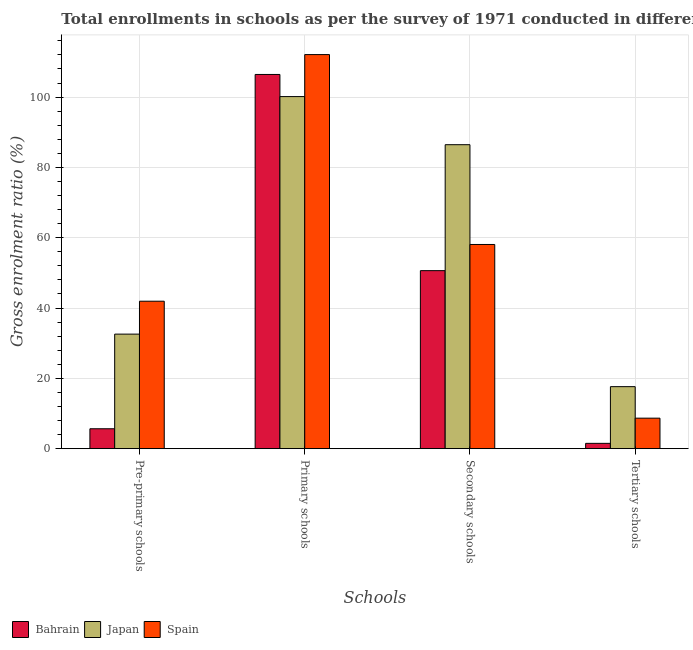How many different coloured bars are there?
Your answer should be very brief. 3. How many groups of bars are there?
Ensure brevity in your answer.  4. Are the number of bars per tick equal to the number of legend labels?
Provide a succinct answer. Yes. How many bars are there on the 4th tick from the right?
Provide a succinct answer. 3. What is the label of the 1st group of bars from the left?
Provide a short and direct response. Pre-primary schools. What is the gross enrolment ratio in tertiary schools in Bahrain?
Provide a short and direct response. 1.51. Across all countries, what is the maximum gross enrolment ratio in secondary schools?
Provide a succinct answer. 86.45. Across all countries, what is the minimum gross enrolment ratio in secondary schools?
Provide a succinct answer. 50.63. In which country was the gross enrolment ratio in primary schools maximum?
Your response must be concise. Spain. In which country was the gross enrolment ratio in pre-primary schools minimum?
Offer a very short reply. Bahrain. What is the total gross enrolment ratio in tertiary schools in the graph?
Ensure brevity in your answer.  27.83. What is the difference between the gross enrolment ratio in secondary schools in Japan and that in Spain?
Keep it short and to the point. 28.38. What is the difference between the gross enrolment ratio in secondary schools in Japan and the gross enrolment ratio in pre-primary schools in Spain?
Offer a terse response. 44.51. What is the average gross enrolment ratio in secondary schools per country?
Make the answer very short. 65.05. What is the difference between the gross enrolment ratio in secondary schools and gross enrolment ratio in primary schools in Japan?
Keep it short and to the point. -13.68. What is the ratio of the gross enrolment ratio in tertiary schools in Japan to that in Bahrain?
Give a very brief answer. 11.66. Is the difference between the gross enrolment ratio in primary schools in Japan and Bahrain greater than the difference between the gross enrolment ratio in secondary schools in Japan and Bahrain?
Make the answer very short. No. What is the difference between the highest and the second highest gross enrolment ratio in primary schools?
Provide a short and direct response. 5.65. What is the difference between the highest and the lowest gross enrolment ratio in pre-primary schools?
Offer a terse response. 36.27. In how many countries, is the gross enrolment ratio in secondary schools greater than the average gross enrolment ratio in secondary schools taken over all countries?
Keep it short and to the point. 1. Is it the case that in every country, the sum of the gross enrolment ratio in primary schools and gross enrolment ratio in secondary schools is greater than the sum of gross enrolment ratio in tertiary schools and gross enrolment ratio in pre-primary schools?
Your answer should be very brief. Yes. What does the 1st bar from the left in Tertiary schools represents?
Provide a succinct answer. Bahrain. How many bars are there?
Provide a short and direct response. 12. What is the difference between two consecutive major ticks on the Y-axis?
Ensure brevity in your answer.  20. Does the graph contain grids?
Ensure brevity in your answer.  Yes. Where does the legend appear in the graph?
Your answer should be compact. Bottom left. How many legend labels are there?
Your response must be concise. 3. How are the legend labels stacked?
Make the answer very short. Horizontal. What is the title of the graph?
Provide a short and direct response. Total enrollments in schools as per the survey of 1971 conducted in different countries. Does "Lao PDR" appear as one of the legend labels in the graph?
Your response must be concise. No. What is the label or title of the X-axis?
Make the answer very short. Schools. What is the label or title of the Y-axis?
Your answer should be compact. Gross enrolment ratio (%). What is the Gross enrolment ratio (%) in Bahrain in Pre-primary schools?
Give a very brief answer. 5.67. What is the Gross enrolment ratio (%) in Japan in Pre-primary schools?
Your response must be concise. 32.58. What is the Gross enrolment ratio (%) in Spain in Pre-primary schools?
Provide a succinct answer. 41.94. What is the Gross enrolment ratio (%) of Bahrain in Primary schools?
Your response must be concise. 106.43. What is the Gross enrolment ratio (%) in Japan in Primary schools?
Keep it short and to the point. 100.14. What is the Gross enrolment ratio (%) in Spain in Primary schools?
Provide a short and direct response. 112.08. What is the Gross enrolment ratio (%) in Bahrain in Secondary schools?
Provide a succinct answer. 50.63. What is the Gross enrolment ratio (%) of Japan in Secondary schools?
Your response must be concise. 86.45. What is the Gross enrolment ratio (%) in Spain in Secondary schools?
Keep it short and to the point. 58.07. What is the Gross enrolment ratio (%) of Bahrain in Tertiary schools?
Your answer should be compact. 1.51. What is the Gross enrolment ratio (%) in Japan in Tertiary schools?
Ensure brevity in your answer.  17.64. What is the Gross enrolment ratio (%) of Spain in Tertiary schools?
Provide a succinct answer. 8.68. Across all Schools, what is the maximum Gross enrolment ratio (%) in Bahrain?
Offer a terse response. 106.43. Across all Schools, what is the maximum Gross enrolment ratio (%) in Japan?
Offer a very short reply. 100.14. Across all Schools, what is the maximum Gross enrolment ratio (%) of Spain?
Your response must be concise. 112.08. Across all Schools, what is the minimum Gross enrolment ratio (%) in Bahrain?
Offer a terse response. 1.51. Across all Schools, what is the minimum Gross enrolment ratio (%) in Japan?
Your response must be concise. 17.64. Across all Schools, what is the minimum Gross enrolment ratio (%) in Spain?
Offer a very short reply. 8.68. What is the total Gross enrolment ratio (%) of Bahrain in the graph?
Your response must be concise. 164.24. What is the total Gross enrolment ratio (%) in Japan in the graph?
Your answer should be very brief. 236.81. What is the total Gross enrolment ratio (%) of Spain in the graph?
Your answer should be very brief. 220.77. What is the difference between the Gross enrolment ratio (%) of Bahrain in Pre-primary schools and that in Primary schools?
Provide a short and direct response. -100.77. What is the difference between the Gross enrolment ratio (%) in Japan in Pre-primary schools and that in Primary schools?
Give a very brief answer. -67.55. What is the difference between the Gross enrolment ratio (%) of Spain in Pre-primary schools and that in Primary schools?
Provide a short and direct response. -70.15. What is the difference between the Gross enrolment ratio (%) in Bahrain in Pre-primary schools and that in Secondary schools?
Provide a short and direct response. -44.97. What is the difference between the Gross enrolment ratio (%) of Japan in Pre-primary schools and that in Secondary schools?
Your answer should be compact. -53.87. What is the difference between the Gross enrolment ratio (%) of Spain in Pre-primary schools and that in Secondary schools?
Provide a succinct answer. -16.14. What is the difference between the Gross enrolment ratio (%) of Bahrain in Pre-primary schools and that in Tertiary schools?
Offer a very short reply. 4.15. What is the difference between the Gross enrolment ratio (%) in Japan in Pre-primary schools and that in Tertiary schools?
Provide a succinct answer. 14.94. What is the difference between the Gross enrolment ratio (%) of Spain in Pre-primary schools and that in Tertiary schools?
Offer a very short reply. 33.26. What is the difference between the Gross enrolment ratio (%) in Bahrain in Primary schools and that in Secondary schools?
Make the answer very short. 55.8. What is the difference between the Gross enrolment ratio (%) in Japan in Primary schools and that in Secondary schools?
Provide a succinct answer. 13.68. What is the difference between the Gross enrolment ratio (%) of Spain in Primary schools and that in Secondary schools?
Make the answer very short. 54.01. What is the difference between the Gross enrolment ratio (%) in Bahrain in Primary schools and that in Tertiary schools?
Ensure brevity in your answer.  104.92. What is the difference between the Gross enrolment ratio (%) in Japan in Primary schools and that in Tertiary schools?
Your response must be concise. 82.5. What is the difference between the Gross enrolment ratio (%) in Spain in Primary schools and that in Tertiary schools?
Give a very brief answer. 103.41. What is the difference between the Gross enrolment ratio (%) in Bahrain in Secondary schools and that in Tertiary schools?
Your answer should be very brief. 49.12. What is the difference between the Gross enrolment ratio (%) in Japan in Secondary schools and that in Tertiary schools?
Your answer should be very brief. 68.81. What is the difference between the Gross enrolment ratio (%) of Spain in Secondary schools and that in Tertiary schools?
Your answer should be very brief. 49.4. What is the difference between the Gross enrolment ratio (%) in Bahrain in Pre-primary schools and the Gross enrolment ratio (%) in Japan in Primary schools?
Keep it short and to the point. -94.47. What is the difference between the Gross enrolment ratio (%) of Bahrain in Pre-primary schools and the Gross enrolment ratio (%) of Spain in Primary schools?
Offer a very short reply. -106.42. What is the difference between the Gross enrolment ratio (%) in Japan in Pre-primary schools and the Gross enrolment ratio (%) in Spain in Primary schools?
Keep it short and to the point. -79.5. What is the difference between the Gross enrolment ratio (%) of Bahrain in Pre-primary schools and the Gross enrolment ratio (%) of Japan in Secondary schools?
Your response must be concise. -80.79. What is the difference between the Gross enrolment ratio (%) in Bahrain in Pre-primary schools and the Gross enrolment ratio (%) in Spain in Secondary schools?
Your answer should be compact. -52.41. What is the difference between the Gross enrolment ratio (%) of Japan in Pre-primary schools and the Gross enrolment ratio (%) of Spain in Secondary schools?
Provide a succinct answer. -25.49. What is the difference between the Gross enrolment ratio (%) of Bahrain in Pre-primary schools and the Gross enrolment ratio (%) of Japan in Tertiary schools?
Your answer should be very brief. -11.97. What is the difference between the Gross enrolment ratio (%) in Bahrain in Pre-primary schools and the Gross enrolment ratio (%) in Spain in Tertiary schools?
Your answer should be very brief. -3.01. What is the difference between the Gross enrolment ratio (%) of Japan in Pre-primary schools and the Gross enrolment ratio (%) of Spain in Tertiary schools?
Your answer should be very brief. 23.9. What is the difference between the Gross enrolment ratio (%) of Bahrain in Primary schools and the Gross enrolment ratio (%) of Japan in Secondary schools?
Offer a very short reply. 19.98. What is the difference between the Gross enrolment ratio (%) in Bahrain in Primary schools and the Gross enrolment ratio (%) in Spain in Secondary schools?
Provide a short and direct response. 48.36. What is the difference between the Gross enrolment ratio (%) of Japan in Primary schools and the Gross enrolment ratio (%) of Spain in Secondary schools?
Offer a terse response. 42.06. What is the difference between the Gross enrolment ratio (%) of Bahrain in Primary schools and the Gross enrolment ratio (%) of Japan in Tertiary schools?
Give a very brief answer. 88.79. What is the difference between the Gross enrolment ratio (%) in Bahrain in Primary schools and the Gross enrolment ratio (%) in Spain in Tertiary schools?
Provide a short and direct response. 97.75. What is the difference between the Gross enrolment ratio (%) of Japan in Primary schools and the Gross enrolment ratio (%) of Spain in Tertiary schools?
Provide a short and direct response. 91.46. What is the difference between the Gross enrolment ratio (%) of Bahrain in Secondary schools and the Gross enrolment ratio (%) of Japan in Tertiary schools?
Provide a succinct answer. 32.99. What is the difference between the Gross enrolment ratio (%) of Bahrain in Secondary schools and the Gross enrolment ratio (%) of Spain in Tertiary schools?
Your answer should be compact. 41.96. What is the difference between the Gross enrolment ratio (%) in Japan in Secondary schools and the Gross enrolment ratio (%) in Spain in Tertiary schools?
Offer a very short reply. 77.77. What is the average Gross enrolment ratio (%) of Bahrain per Schools?
Make the answer very short. 41.06. What is the average Gross enrolment ratio (%) of Japan per Schools?
Offer a terse response. 59.2. What is the average Gross enrolment ratio (%) in Spain per Schools?
Make the answer very short. 55.19. What is the difference between the Gross enrolment ratio (%) in Bahrain and Gross enrolment ratio (%) in Japan in Pre-primary schools?
Make the answer very short. -26.92. What is the difference between the Gross enrolment ratio (%) in Bahrain and Gross enrolment ratio (%) in Spain in Pre-primary schools?
Give a very brief answer. -36.27. What is the difference between the Gross enrolment ratio (%) in Japan and Gross enrolment ratio (%) in Spain in Pre-primary schools?
Keep it short and to the point. -9.36. What is the difference between the Gross enrolment ratio (%) in Bahrain and Gross enrolment ratio (%) in Japan in Primary schools?
Keep it short and to the point. 6.29. What is the difference between the Gross enrolment ratio (%) in Bahrain and Gross enrolment ratio (%) in Spain in Primary schools?
Offer a terse response. -5.65. What is the difference between the Gross enrolment ratio (%) in Japan and Gross enrolment ratio (%) in Spain in Primary schools?
Provide a short and direct response. -11.95. What is the difference between the Gross enrolment ratio (%) in Bahrain and Gross enrolment ratio (%) in Japan in Secondary schools?
Give a very brief answer. -35.82. What is the difference between the Gross enrolment ratio (%) of Bahrain and Gross enrolment ratio (%) of Spain in Secondary schools?
Your response must be concise. -7.44. What is the difference between the Gross enrolment ratio (%) of Japan and Gross enrolment ratio (%) of Spain in Secondary schools?
Offer a terse response. 28.38. What is the difference between the Gross enrolment ratio (%) in Bahrain and Gross enrolment ratio (%) in Japan in Tertiary schools?
Make the answer very short. -16.13. What is the difference between the Gross enrolment ratio (%) in Bahrain and Gross enrolment ratio (%) in Spain in Tertiary schools?
Make the answer very short. -7.16. What is the difference between the Gross enrolment ratio (%) in Japan and Gross enrolment ratio (%) in Spain in Tertiary schools?
Give a very brief answer. 8.96. What is the ratio of the Gross enrolment ratio (%) in Bahrain in Pre-primary schools to that in Primary schools?
Give a very brief answer. 0.05. What is the ratio of the Gross enrolment ratio (%) of Japan in Pre-primary schools to that in Primary schools?
Your response must be concise. 0.33. What is the ratio of the Gross enrolment ratio (%) of Spain in Pre-primary schools to that in Primary schools?
Offer a very short reply. 0.37. What is the ratio of the Gross enrolment ratio (%) of Bahrain in Pre-primary schools to that in Secondary schools?
Offer a very short reply. 0.11. What is the ratio of the Gross enrolment ratio (%) in Japan in Pre-primary schools to that in Secondary schools?
Your answer should be compact. 0.38. What is the ratio of the Gross enrolment ratio (%) of Spain in Pre-primary schools to that in Secondary schools?
Give a very brief answer. 0.72. What is the ratio of the Gross enrolment ratio (%) in Bahrain in Pre-primary schools to that in Tertiary schools?
Give a very brief answer. 3.74. What is the ratio of the Gross enrolment ratio (%) of Japan in Pre-primary schools to that in Tertiary schools?
Provide a short and direct response. 1.85. What is the ratio of the Gross enrolment ratio (%) of Spain in Pre-primary schools to that in Tertiary schools?
Give a very brief answer. 4.83. What is the ratio of the Gross enrolment ratio (%) in Bahrain in Primary schools to that in Secondary schools?
Provide a short and direct response. 2.1. What is the ratio of the Gross enrolment ratio (%) of Japan in Primary schools to that in Secondary schools?
Ensure brevity in your answer.  1.16. What is the ratio of the Gross enrolment ratio (%) in Spain in Primary schools to that in Secondary schools?
Your response must be concise. 1.93. What is the ratio of the Gross enrolment ratio (%) of Bahrain in Primary schools to that in Tertiary schools?
Provide a succinct answer. 70.32. What is the ratio of the Gross enrolment ratio (%) in Japan in Primary schools to that in Tertiary schools?
Provide a short and direct response. 5.68. What is the ratio of the Gross enrolment ratio (%) of Spain in Primary schools to that in Tertiary schools?
Provide a succinct answer. 12.92. What is the ratio of the Gross enrolment ratio (%) in Bahrain in Secondary schools to that in Tertiary schools?
Your answer should be compact. 33.46. What is the ratio of the Gross enrolment ratio (%) in Japan in Secondary schools to that in Tertiary schools?
Ensure brevity in your answer.  4.9. What is the ratio of the Gross enrolment ratio (%) in Spain in Secondary schools to that in Tertiary schools?
Keep it short and to the point. 6.69. What is the difference between the highest and the second highest Gross enrolment ratio (%) of Bahrain?
Make the answer very short. 55.8. What is the difference between the highest and the second highest Gross enrolment ratio (%) in Japan?
Offer a very short reply. 13.68. What is the difference between the highest and the second highest Gross enrolment ratio (%) in Spain?
Provide a succinct answer. 54.01. What is the difference between the highest and the lowest Gross enrolment ratio (%) in Bahrain?
Offer a very short reply. 104.92. What is the difference between the highest and the lowest Gross enrolment ratio (%) of Japan?
Provide a short and direct response. 82.5. What is the difference between the highest and the lowest Gross enrolment ratio (%) of Spain?
Your answer should be compact. 103.41. 